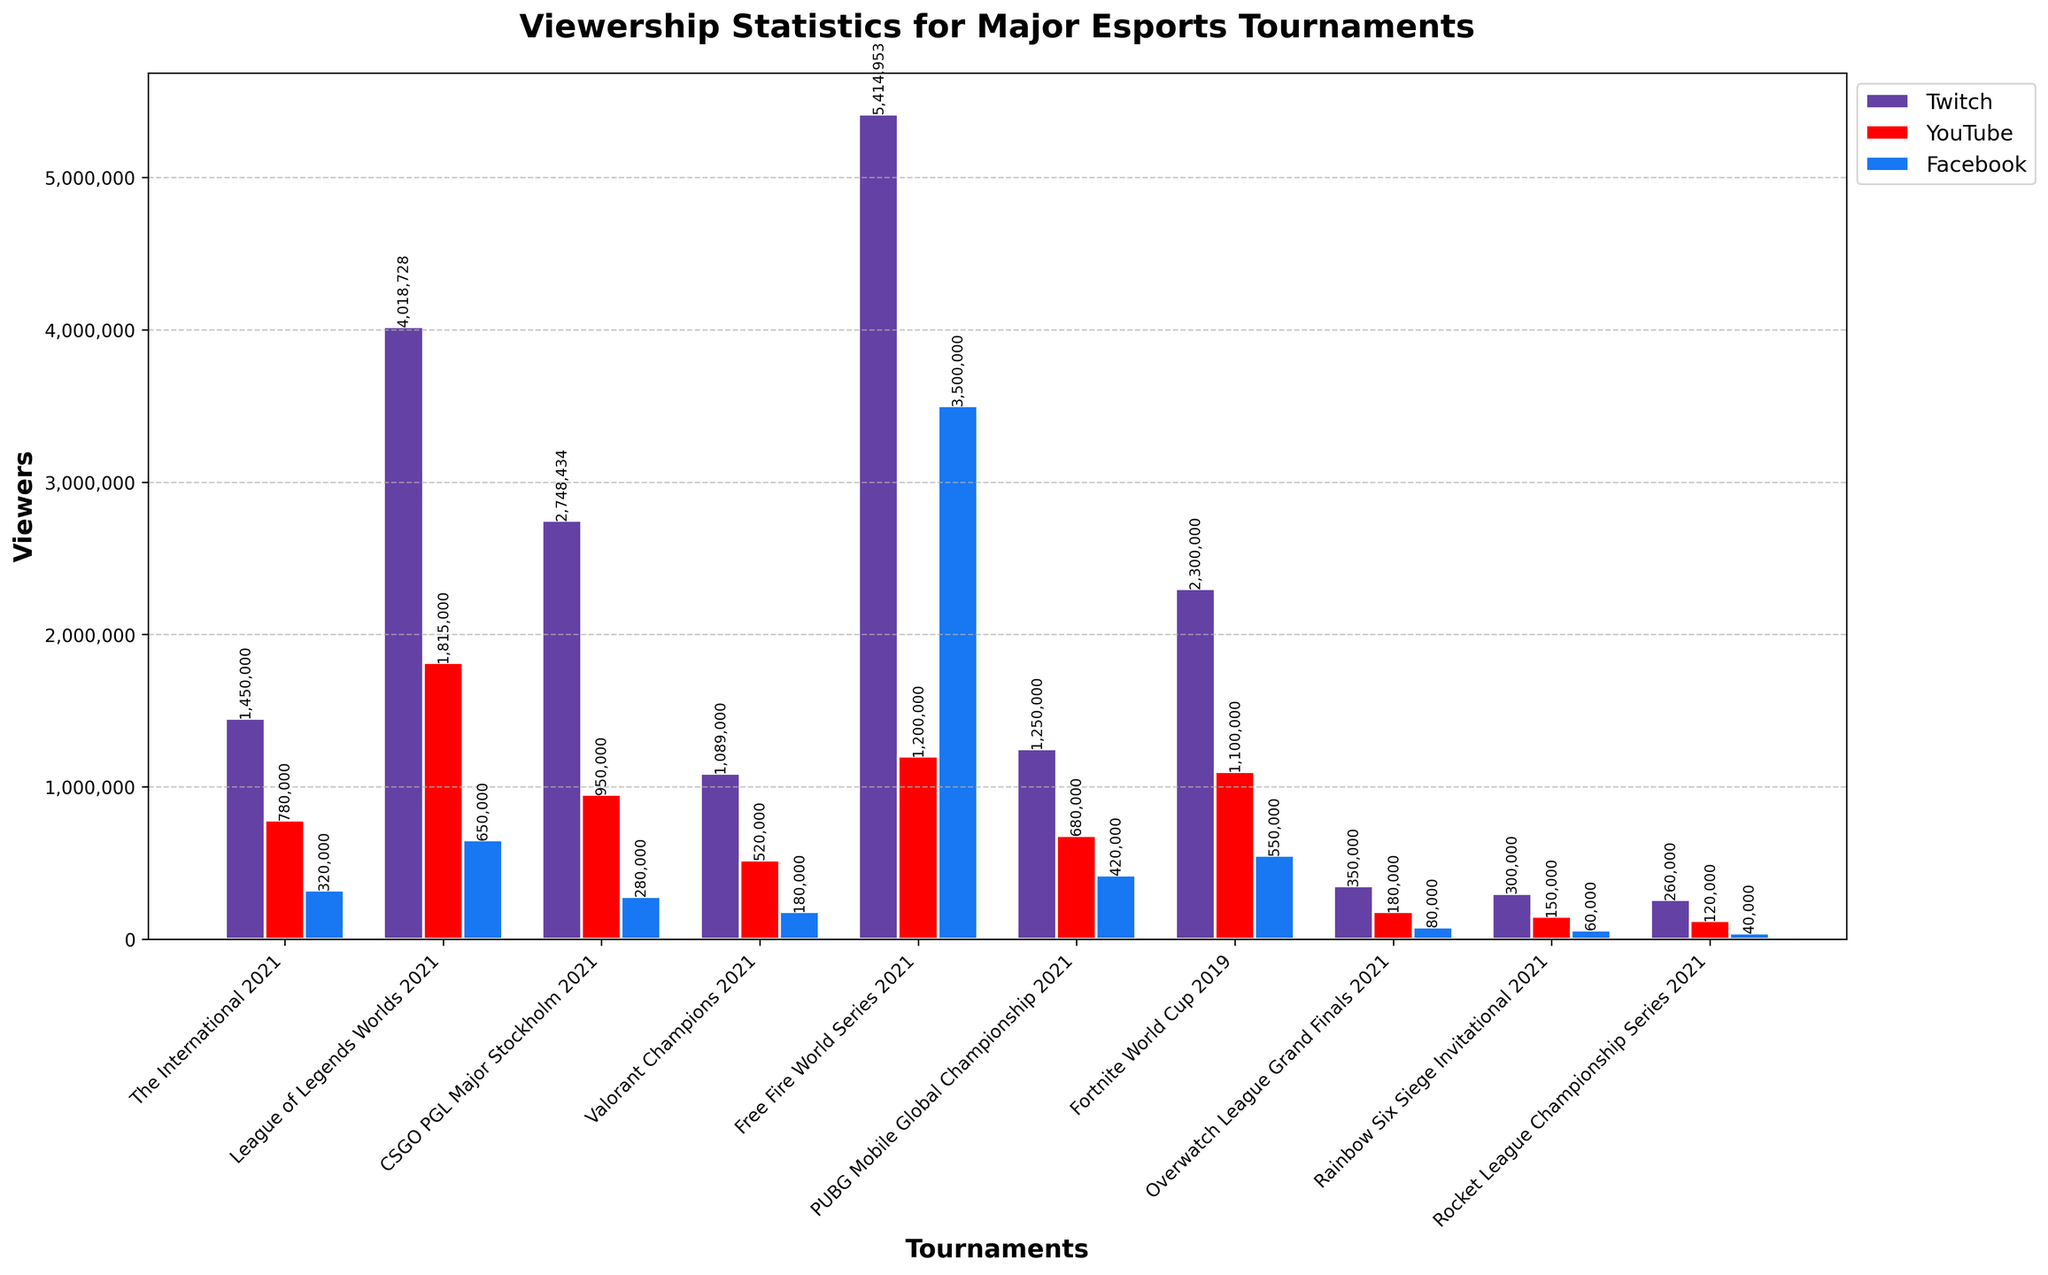What is the tournament with the highest total viewership across all platforms? Sum the viewership numbers for Twitch, YouTube, and Facebook for each tournament. The International 2021 equals 1450000 + 780000 + 320000 = 2550000; League of Legends Worlds 2021 equals 4018728 + 1815000 + 650000 = 6483728; and so on. The highest total is for Free Fire World Series 2021 with 5414953 + 1200000 + 3500000 = 10114953.
Answer: Free Fire World Series 2021 How many tournaments have more YouTube viewers than Facebook viewers? Compare the YouTube and Facebook viewers for each tournament: The International 2021 (780000 vs 320000), League of Legends Worlds 2021 (1815000 vs 650000), CSGO PGL Major Stockholm 2021 (950000 vs 280000), and so on. Tournaments with more YouTube viewers are The International 2021, League of Legends Worlds 2021, CSGO PGL Major Stockholm 2021, Valorant Champions 2021, PUBG Mobile Global Championship 2021, Fortnite World Cup 2019, Overwatch League Grand Finals 2021, Rainbow Six Siege Invitational 2021, Rocket League Championship Series 2021. Count them.
Answer: 9 Which platform has the lowest viewership for the Valorant Champions 2021 tournament? Look at the viewership numbers for Valorant Champions 2021: Twitch = 1089000, YouTube = 520000, and Facebook = 180000. The lowest number is for Facebook.
Answer: Facebook What is the difference in Twitch viewership between League of Legends Worlds 2021 and The International 2021? Look at the Twitch viewership numbers for both tournaments: League of Legends Worlds 2021 = 4018728 and The International 2021 = 1450000. The difference is 4018728 - 1450000 = 2568728.
Answer: 2568728 Which tournament has the smallest viewership on all platforms? Compare the sum of viewership on all platforms for each tournament: The International 2021 = 2550000, League of Legends Worlds 2021 = 6483728, CSGO PGL Major Stockholm 2021 = 3978434, etc. The smallest total is for Rocket League Championship Series 2021 with 260000 + 120000 + 40000 = 420000.
Answer: Rocket League Championship Series 2021 What is the average number of Twitch viewers for all tournaments? Sum the Twitch viewers for all tournaments and divide by the number of tournaments. (1450000 + 4018728 + 2748434 + 1089000 + 5414953 + 1250000 + 2300000 + 350000 + 300000 + 260000) / 10 = 24160115 / 10 = 2416011.5.
Answer: 2416011.5 Does Facebook ever have higher viewership than Twitch for any tournament? Compare the Facebook and Twitch viewers for each tournament: The International 2021 (320000 vs 1450000), League of Legends Worlds 2021 (650000 vs 4018728), etc. None of the tournaments show Facebook having higher viewership than Twitch.
Answer: No 